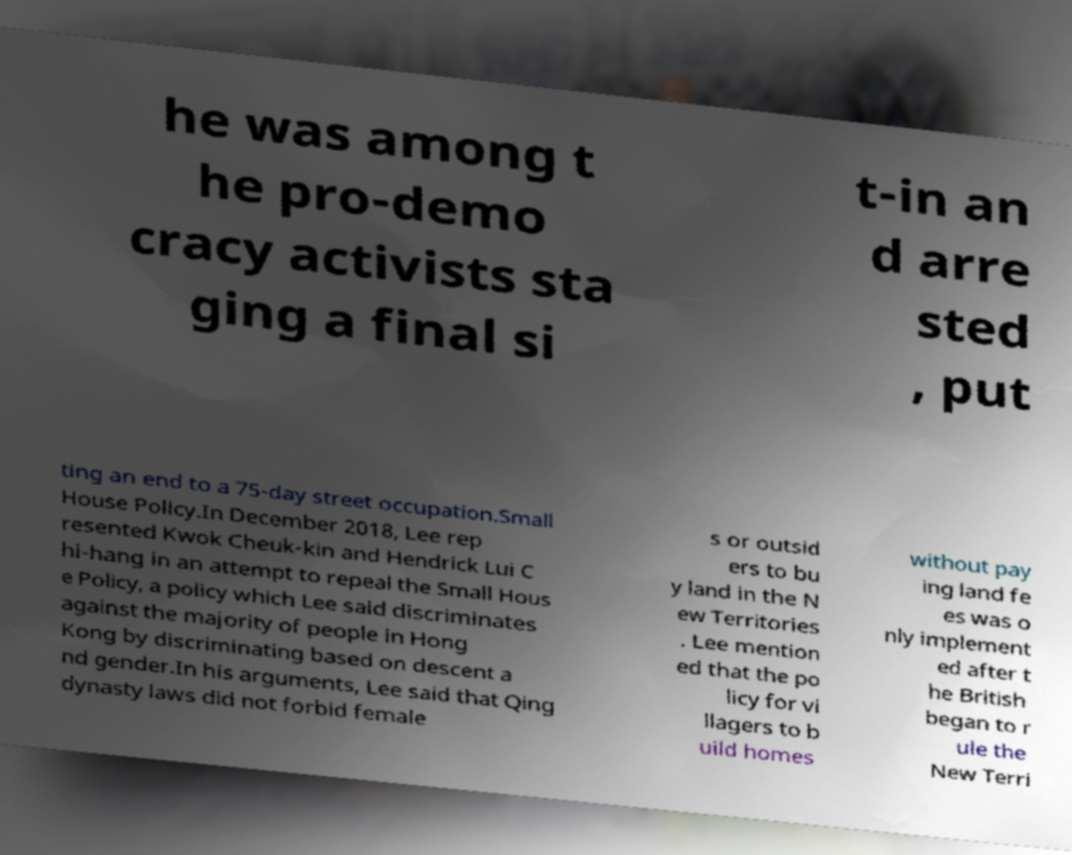Could you extract and type out the text from this image? he was among t he pro-demo cracy activists sta ging a final si t-in an d arre sted , put ting an end to a 75-day street occupation.Small House Policy.In December 2018, Lee rep resented Kwok Cheuk-kin and Hendrick Lui C hi-hang in an attempt to repeal the Small Hous e Policy, a policy which Lee said discriminates against the majority of people in Hong Kong by discriminating based on descent a nd gender.In his arguments, Lee said that Qing dynasty laws did not forbid female s or outsid ers to bu y land in the N ew Territories . Lee mention ed that the po licy for vi llagers to b uild homes without pay ing land fe es was o nly implement ed after t he British began to r ule the New Terri 